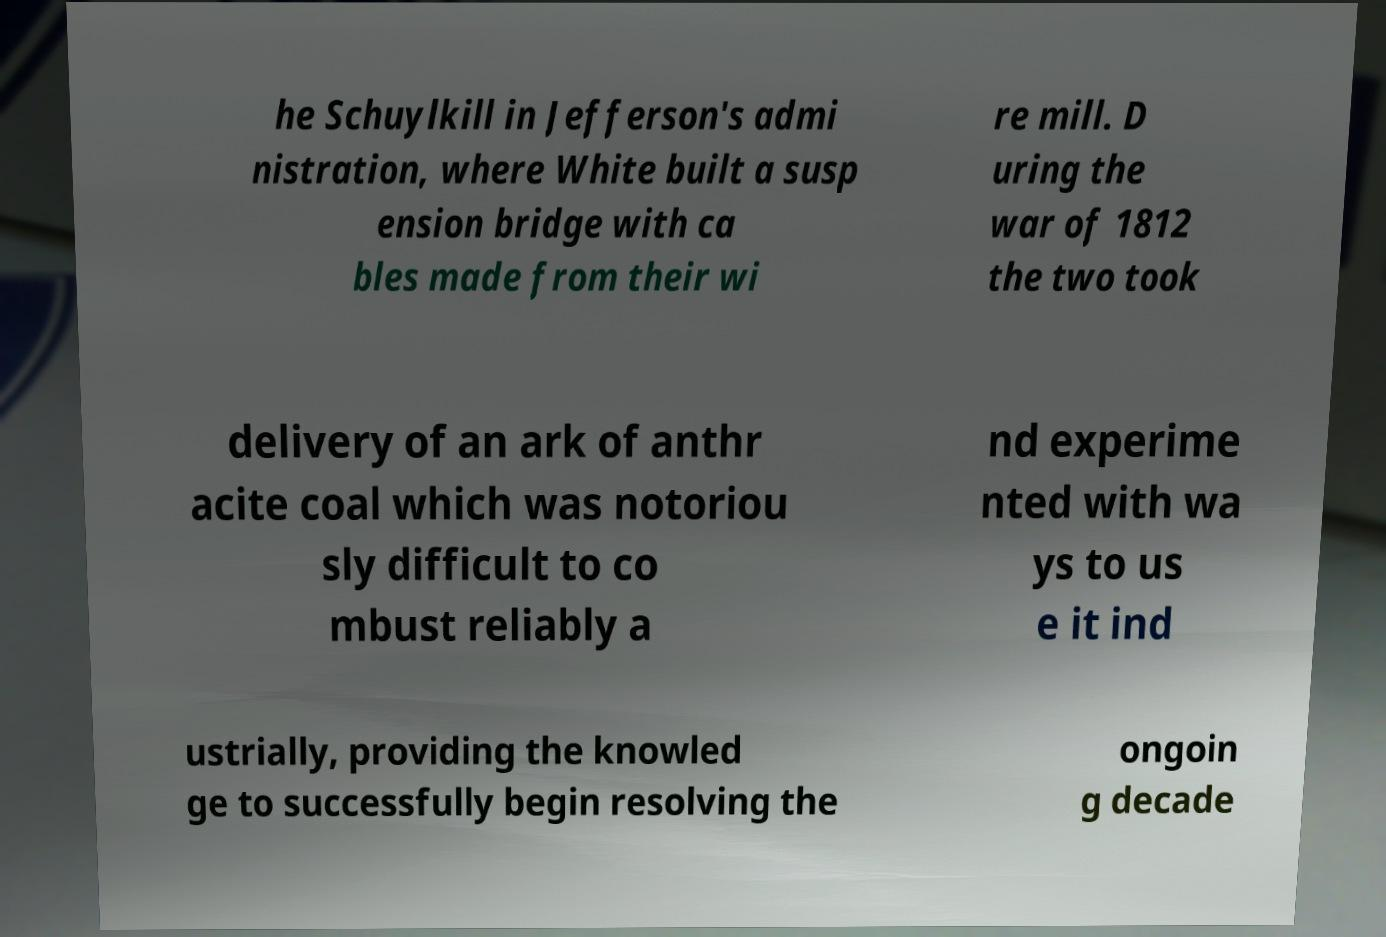Please read and relay the text visible in this image. What does it say? he Schuylkill in Jefferson's admi nistration, where White built a susp ension bridge with ca bles made from their wi re mill. D uring the war of 1812 the two took delivery of an ark of anthr acite coal which was notoriou sly difficult to co mbust reliably a nd experime nted with wa ys to us e it ind ustrially, providing the knowled ge to successfully begin resolving the ongoin g decade 